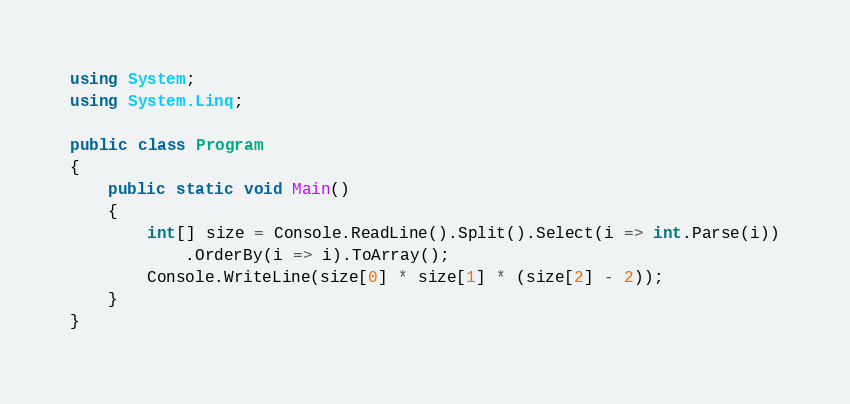<code> <loc_0><loc_0><loc_500><loc_500><_C#_>using System;
using System.Linq;

public class Program
{
	public static void Main()
	{
		int[] size = Console.ReadLine().Split().Select(i => int.Parse(i))
			.OrderBy(i => i).ToArray();
		Console.WriteLine(size[0] * size[1] * (size[2] - 2));
	}
}</code> 